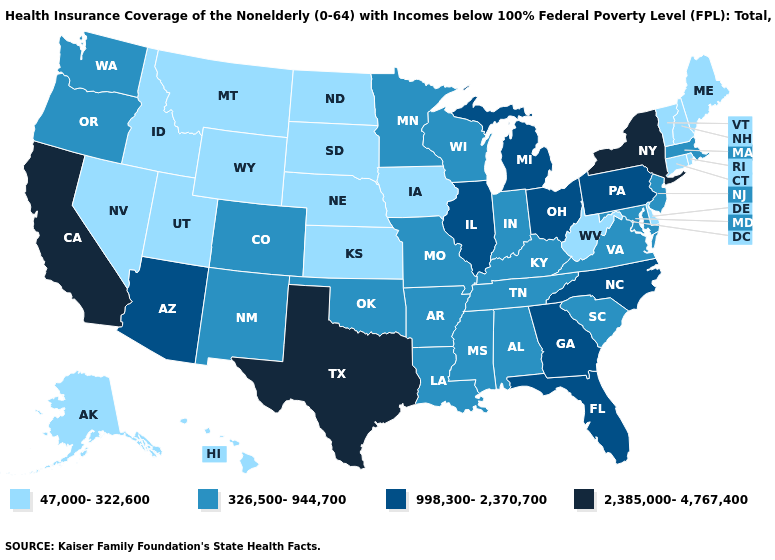What is the highest value in states that border Vermont?
Short answer required. 2,385,000-4,767,400. Name the states that have a value in the range 998,300-2,370,700?
Be succinct. Arizona, Florida, Georgia, Illinois, Michigan, North Carolina, Ohio, Pennsylvania. What is the lowest value in states that border North Dakota?
Keep it brief. 47,000-322,600. What is the value of North Carolina?
Keep it brief. 998,300-2,370,700. Does Oregon have a higher value than New Hampshire?
Short answer required. Yes. Is the legend a continuous bar?
Write a very short answer. No. What is the lowest value in states that border North Carolina?
Give a very brief answer. 326,500-944,700. What is the value of Oregon?
Short answer required. 326,500-944,700. What is the highest value in states that border Montana?
Write a very short answer. 47,000-322,600. What is the value of Vermont?
Be succinct. 47,000-322,600. Among the states that border Alabama , does Georgia have the highest value?
Give a very brief answer. Yes. Does the first symbol in the legend represent the smallest category?
Answer briefly. Yes. What is the value of Texas?
Quick response, please. 2,385,000-4,767,400. Does Indiana have a higher value than New Hampshire?
Give a very brief answer. Yes. What is the highest value in the USA?
Answer briefly. 2,385,000-4,767,400. 